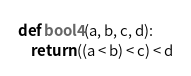<code> <loc_0><loc_0><loc_500><loc_500><_Python_>def bool4(a, b, c, d):
    return ((a < b) < c) < d
</code> 